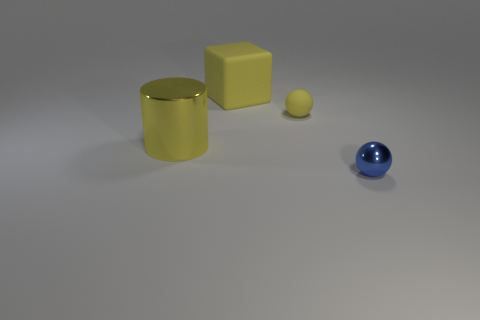What is the color of the thing that is the same material as the yellow cube?
Give a very brief answer. Yellow. Is there anything else that has the same size as the cylinder?
Provide a short and direct response. Yes. What number of large yellow shiny cylinders are in front of the large metallic object?
Offer a very short reply. 0. Does the tiny ball in front of the large cylinder have the same color as the metallic object behind the metal sphere?
Make the answer very short. No. The other shiny thing that is the same shape as the small yellow object is what color?
Give a very brief answer. Blue. Are there any other things that have the same shape as the blue shiny thing?
Make the answer very short. Yes. Do the tiny object to the right of the yellow ball and the yellow matte thing that is on the right side of the cube have the same shape?
Make the answer very short. Yes. There is a yellow rubber sphere; is it the same size as the object on the left side of the yellow cube?
Offer a very short reply. No. Is the number of big blue metallic balls greater than the number of big cylinders?
Offer a very short reply. No. Are the small ball that is behind the yellow metal thing and the big yellow thing in front of the big cube made of the same material?
Provide a succinct answer. No. 